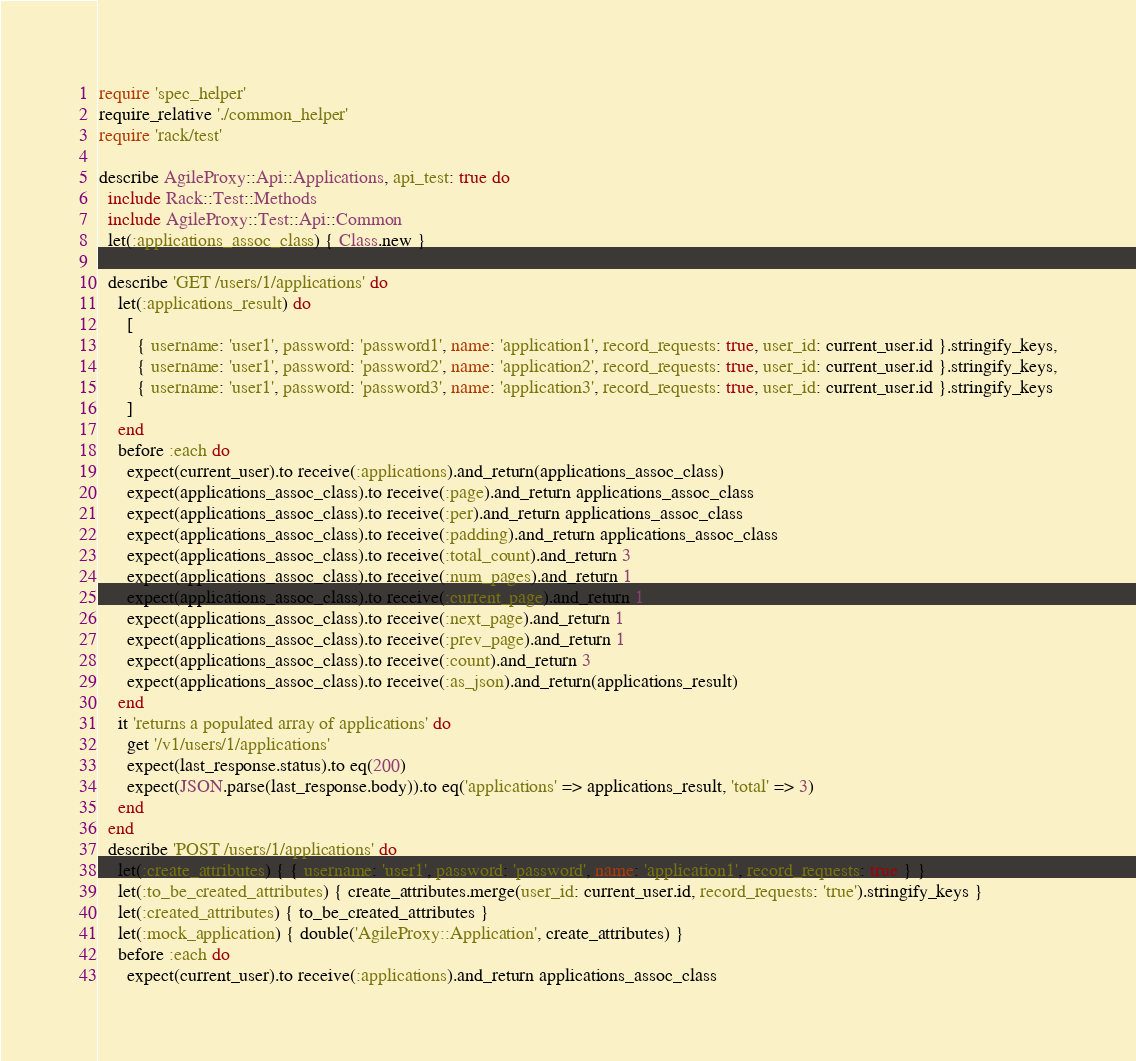Convert code to text. <code><loc_0><loc_0><loc_500><loc_500><_Ruby_>require 'spec_helper'
require_relative './common_helper'
require 'rack/test'

describe AgileProxy::Api::Applications, api_test: true do
  include Rack::Test::Methods
  include AgileProxy::Test::Api::Common
  let(:applications_assoc_class) { Class.new }

  describe 'GET /users/1/applications' do
    let(:applications_result) do
      [
        { username: 'user1', password: 'password1', name: 'application1', record_requests: true, user_id: current_user.id }.stringify_keys,
        { username: 'user1', password: 'password2', name: 'application2', record_requests: true, user_id: current_user.id }.stringify_keys,
        { username: 'user1', password: 'password3', name: 'application3', record_requests: true, user_id: current_user.id }.stringify_keys
      ]
    end
    before :each do
      expect(current_user).to receive(:applications).and_return(applications_assoc_class)
      expect(applications_assoc_class).to receive(:page).and_return applications_assoc_class
      expect(applications_assoc_class).to receive(:per).and_return applications_assoc_class
      expect(applications_assoc_class).to receive(:padding).and_return applications_assoc_class
      expect(applications_assoc_class).to receive(:total_count).and_return 3
      expect(applications_assoc_class).to receive(:num_pages).and_return 1
      expect(applications_assoc_class).to receive(:current_page).and_return 1
      expect(applications_assoc_class).to receive(:next_page).and_return 1
      expect(applications_assoc_class).to receive(:prev_page).and_return 1
      expect(applications_assoc_class).to receive(:count).and_return 3
      expect(applications_assoc_class).to receive(:as_json).and_return(applications_result)
    end
    it 'returns a populated array of applications' do
      get '/v1/users/1/applications'
      expect(last_response.status).to eq(200)
      expect(JSON.parse(last_response.body)).to eq('applications' => applications_result, 'total' => 3)
    end
  end
  describe 'POST /users/1/applications' do
    let(:create_attributes) { { username: 'user1', password: 'password', name: 'application1', record_requests: true } }
    let(:to_be_created_attributes) { create_attributes.merge(user_id: current_user.id, record_requests: 'true').stringify_keys }
    let(:created_attributes) { to_be_created_attributes }
    let(:mock_application) { double('AgileProxy::Application', create_attributes) }
    before :each do
      expect(current_user).to receive(:applications).and_return applications_assoc_class</code> 